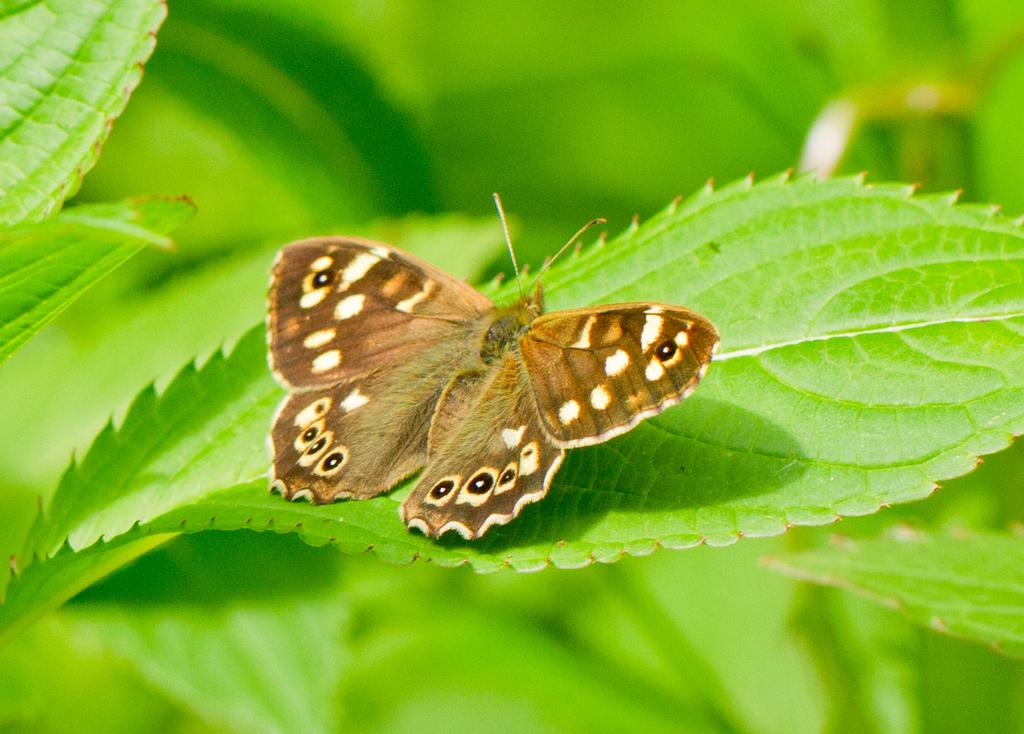What type of insect is in the image? There is a brown butterfly in the image. Where is the butterfly located? The butterfly is on a green leaf. Can you describe the background of the image? The background of the image is blurry. What type of blade can be seen cutting through the butterfly in the image? There is no blade cutting through the butterfly in the image; the butterfly is on a green leaf. How many kittens are playing with the butterfly in the image? There are no kittens present in the image; it features a brown butterfly on a green leaf. 